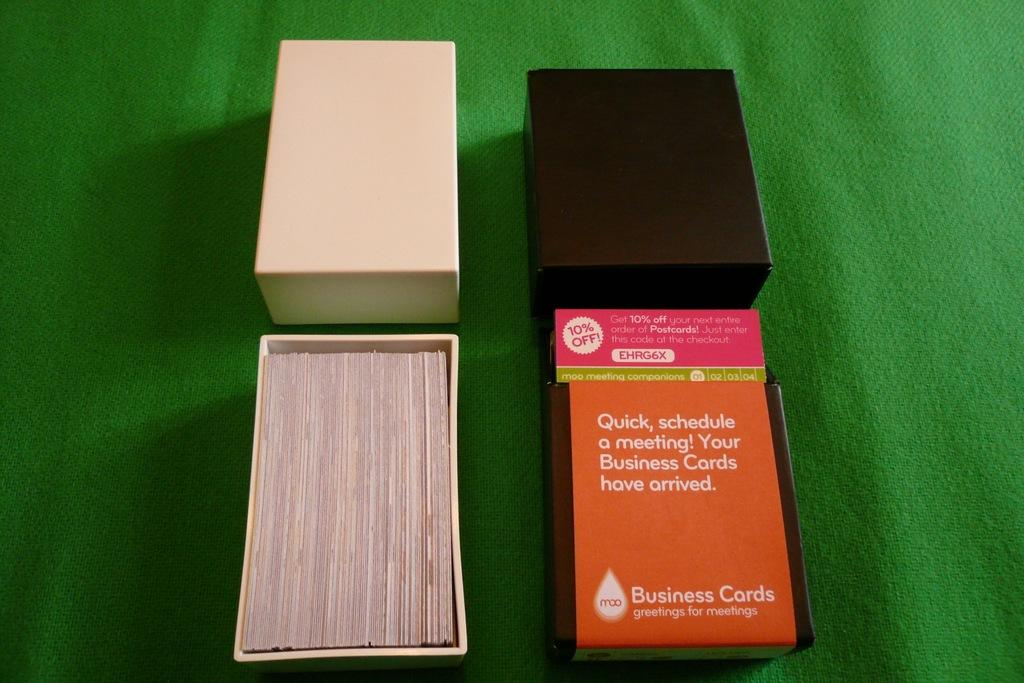<image>
Provide a brief description of the given image. An open box of Moo Business Cards on green felt. 